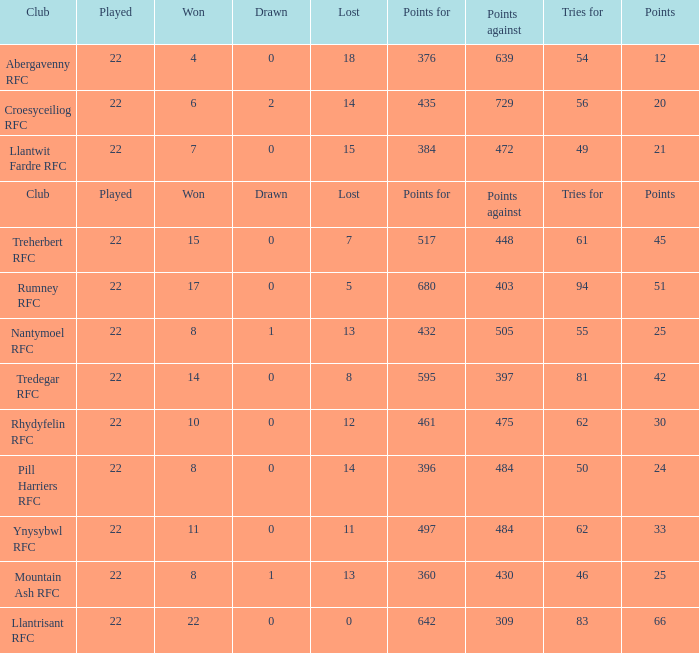How many tries for were scored by the team that had exactly 396 points for? 50.0. 